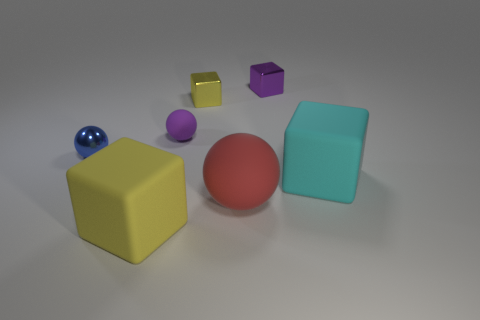Add 2 purple metallic blocks. How many objects exist? 9 Subtract all cubes. How many objects are left? 3 Add 4 red spheres. How many red spheres are left? 5 Add 3 metallic balls. How many metallic balls exist? 4 Subtract 0 cyan cylinders. How many objects are left? 7 Subtract all cylinders. Subtract all matte balls. How many objects are left? 5 